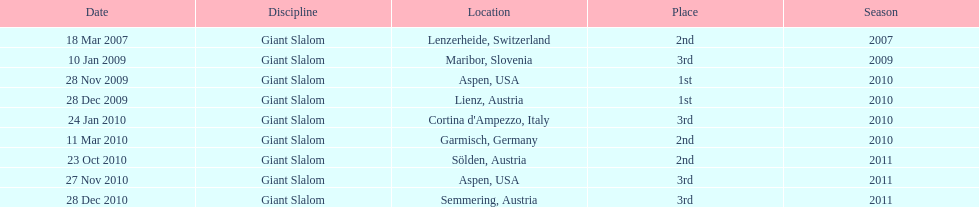The final race finishing place was not 1st but what other place? 3rd. 